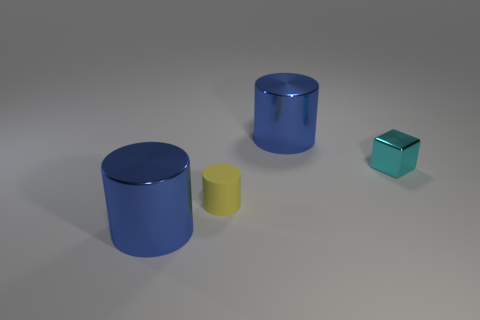Are there any other things that are made of the same material as the small yellow cylinder?
Your response must be concise. No. The tiny metallic thing right of the yellow thing has what shape?
Provide a short and direct response. Cube. There is a yellow rubber cylinder; are there any tiny yellow cylinders behind it?
Give a very brief answer. No. Does the big metallic cylinder on the right side of the tiny cylinder have the same color as the shiny object in front of the tiny yellow rubber cylinder?
Provide a succinct answer. Yes. What number of cylinders are either shiny objects or small rubber things?
Give a very brief answer. 3. Are there the same number of metallic blocks that are in front of the tiny cyan thing and tiny cyan cubes?
Your answer should be compact. No. The large cylinder that is in front of the yellow rubber cylinder behind the large blue object in front of the tiny cyan metal cube is made of what material?
Ensure brevity in your answer.  Metal. What number of objects are small things in front of the cyan thing or matte cylinders?
Provide a succinct answer. 1. How many things are cubes or large blue metal cylinders that are in front of the tiny matte object?
Make the answer very short. 2. How many objects are behind the tiny thing left of the blue cylinder behind the tiny metallic cube?
Ensure brevity in your answer.  2. 